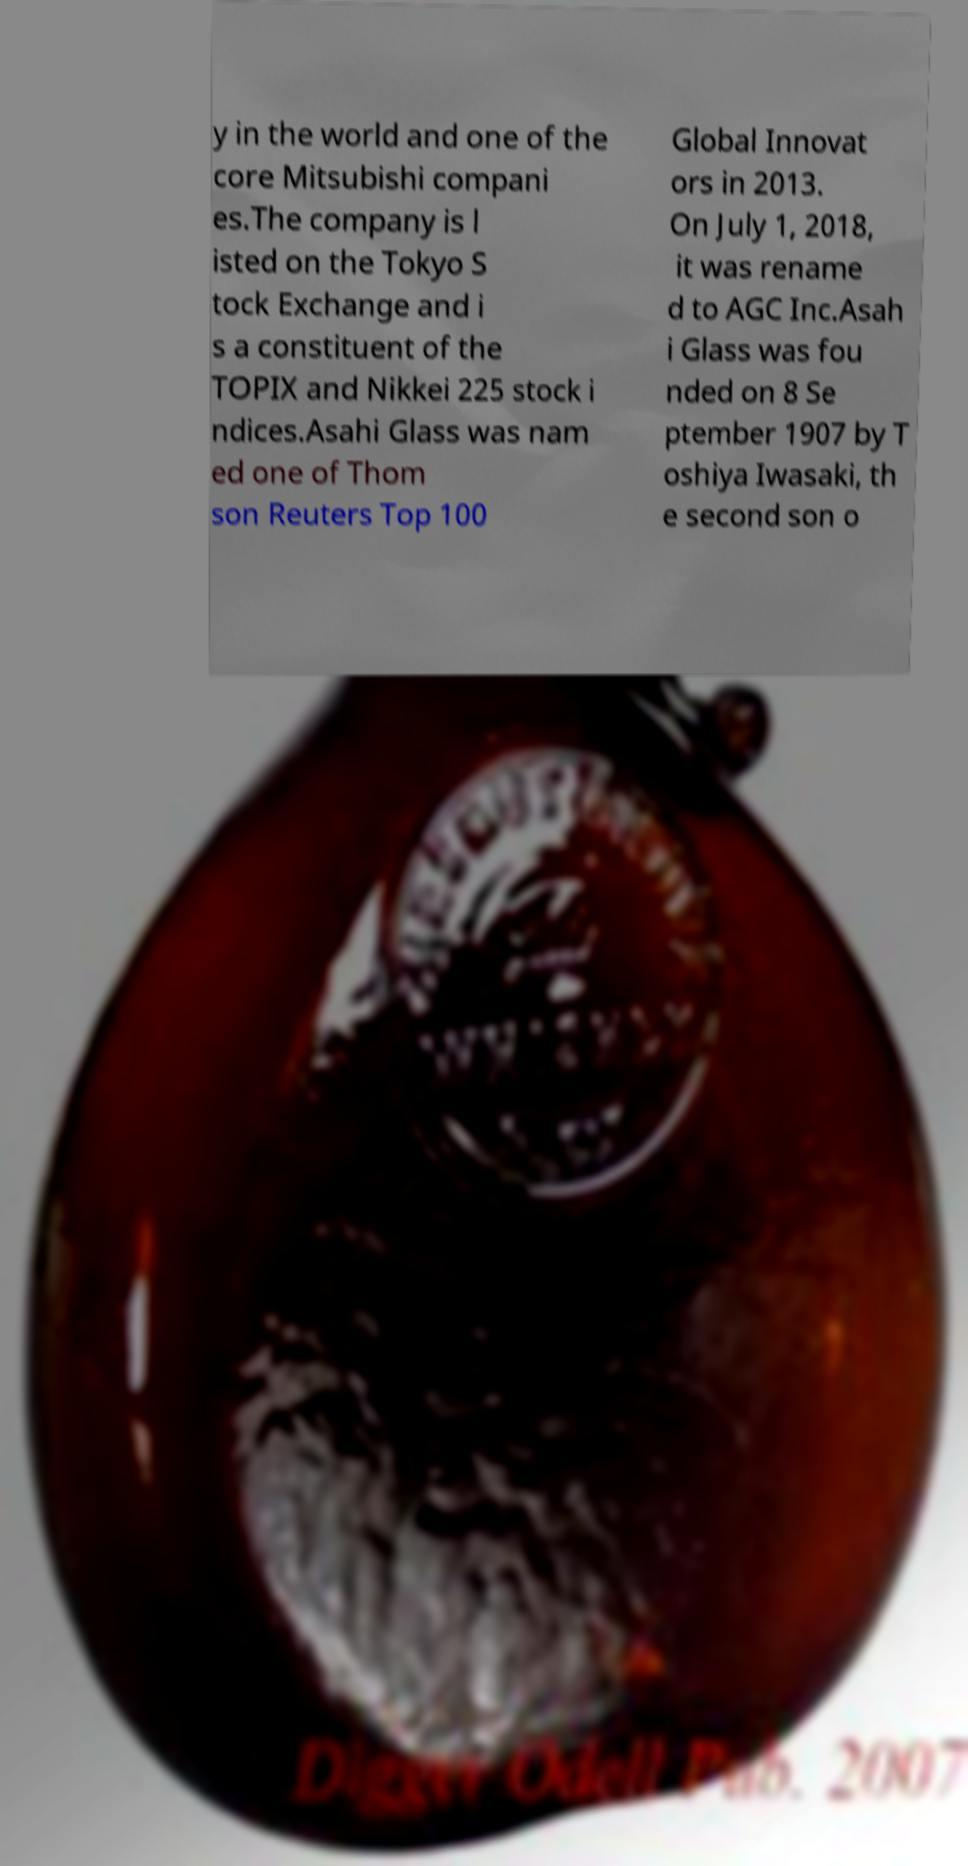There's text embedded in this image that I need extracted. Can you transcribe it verbatim? y in the world and one of the core Mitsubishi compani es.The company is l isted on the Tokyo S tock Exchange and i s a constituent of the TOPIX and Nikkei 225 stock i ndices.Asahi Glass was nam ed one of Thom son Reuters Top 100 Global Innovat ors in 2013. On July 1, 2018, it was rename d to AGC Inc.Asah i Glass was fou nded on 8 Se ptember 1907 by T oshiya Iwasaki, th e second son o 